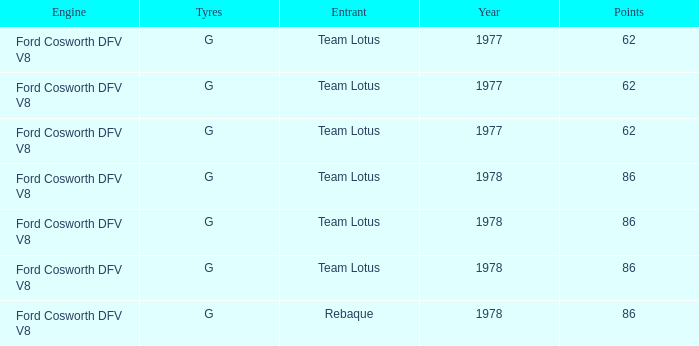What is the Motor that has a Focuses bigger than 62, and a Participant of rebaque? Ford Cosworth DFV V8. 